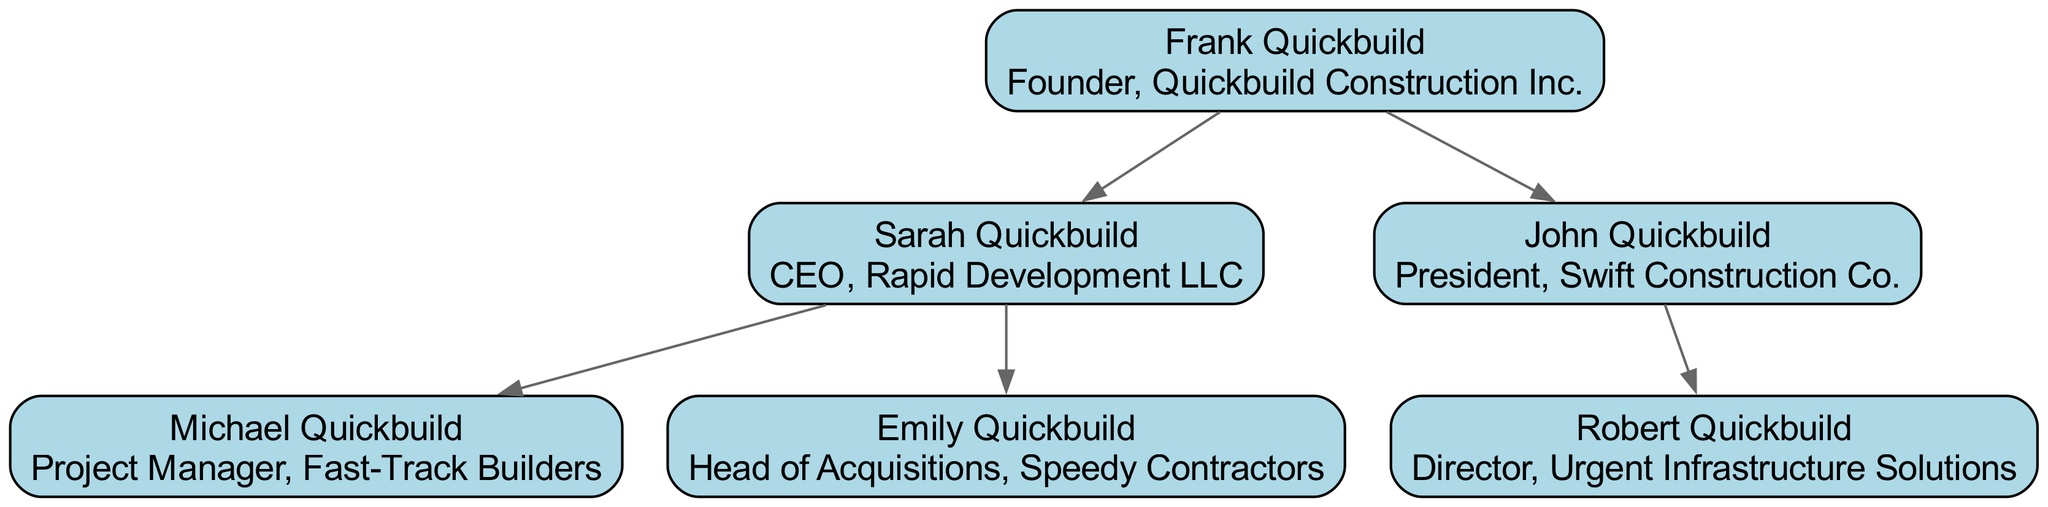What is the role of Frank Quickbuild? Frank Quickbuild is identified as the founder of Quickbuild Construction Inc. in the diagram, which designates his primary function and title.
Answer: Founder, Quickbuild Construction Inc How many children does Sarah Quickbuild have? The diagram shows that Sarah Quickbuild has two children: Michael Quickbuild and Emily Quickbuild, which can be seen as branches from her node.
Answer: 2 Who is the director at Urgent Infrastructure Solutions? The diagram specifies that Robert Quickbuild holds the position of Director at Urgent Infrastructure Solutions, directly linked to his parent, John Quickbuild.
Answer: Robert Quickbuild Which company does John Quickbuild preside over? According to the diagram, John Quickbuild is positioned as the president of Swift Construction Co., which is directly indicated beside his name.
Answer: Swift Construction Co Who is Emily Quickbuild’s father? Tracing the connections in the diagram, Emily Quickbuild is shown as a child of Sarah Quickbuild, who is married to Frank Quickbuild, making Frank her grandfather. Therefore, Sarah's role is a direct relationship.
Answer: Frank Quickbuild How many total executives are represented in this family tree? By counting all distinct nodes in the tree, including Frank Quickbuild, Sarah, John, Michael, Emily, and Robert, we arrive at a total of six executives depicted in the diagram.
Answer: 6 Which executive role is associated with Quickbuild Construction Inc.? The diagram explicitly denotes Frank Quickbuild as the founder of Quickbuild Construction Inc., indicating his executive position specifically tied to that organization.
Answer: Founder Which company does Michael Quickbuild work for? The diagram directly states that Michael Quickbuild serves as Project Manager for Fast-Track Builders, linking his role specifically to that company.
Answer: Fast-Track Builders What type of diagram is being represented here? The structure and hierarchical nature of the connections clearly show that this is a family tree diagram, focusing on familial relationships and roles within a specific industry context.
Answer: Family tree 